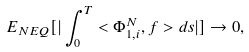Convert formula to latex. <formula><loc_0><loc_0><loc_500><loc_500>E _ { N E Q } [ | \int _ { 0 } ^ { T } < \Phi _ { 1 , i } ^ { N } , f > d s | ] \rightarrow 0 ,</formula> 